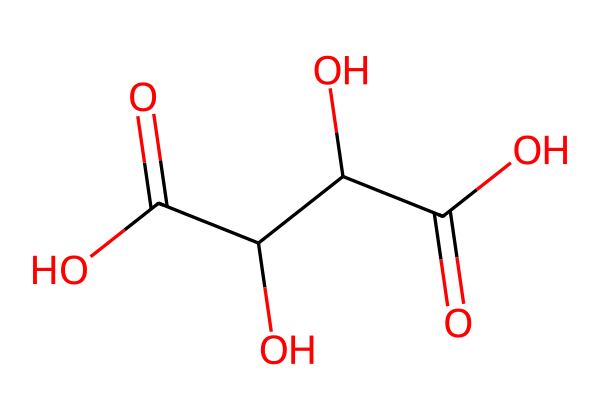What is the molecular formula of tartaric acid? To find the molecular formula, we count the number of each type of atom in the chemical's structure as represented by the SMILES. The structure has 4 carbon (C) atoms, 6 hydrogen (H) atoms, and 5 oxygen (O) atoms. Combining these counts gives us the molecular formula of C4H6O6.
Answer: C4H6O6 How many hydroxyl (-OH) groups are present in this structure? The structure contains three hydroxyl groups, which are shown as -OH in the SMILES. By identifying these groups within the molecular representation, we see there are three instances of -OH.
Answer: 3 Is tartaric acid a saturated or unsaturated compound? Saturated compounds contain only single bonds between carbon atoms. In the structure of tartaric acid, all carbon atoms are connected by single bonds; therefore, it is a saturated compound.
Answer: saturated What type of acid is tartaric acid? Tartaric acid is classified as a dicarboxylic acid due to the presence of two carboxyl (-COOH) groups in its structure, which are indicated by the two occurrences of C(=O)O in the SMILES.
Answer: dicarboxylic How many total atoms are there in the molecule of tartaric acid? We calculate the total number of atoms by adding the number of carbon, hydrogen, and oxygen atoms based on the molecular formula C4H6O6. This yields a total of 4 + 6 + 6 = 16 atoms in total.
Answer: 16 What is the significance of tartaric acid in winemaking? Tartaric acid plays a crucial role in stabilizing the wine's pH and contributes to its taste; it helps maintain acidity levels in the final product, which is essential for the balance of flavor in wine.
Answer: stabilizes pH 